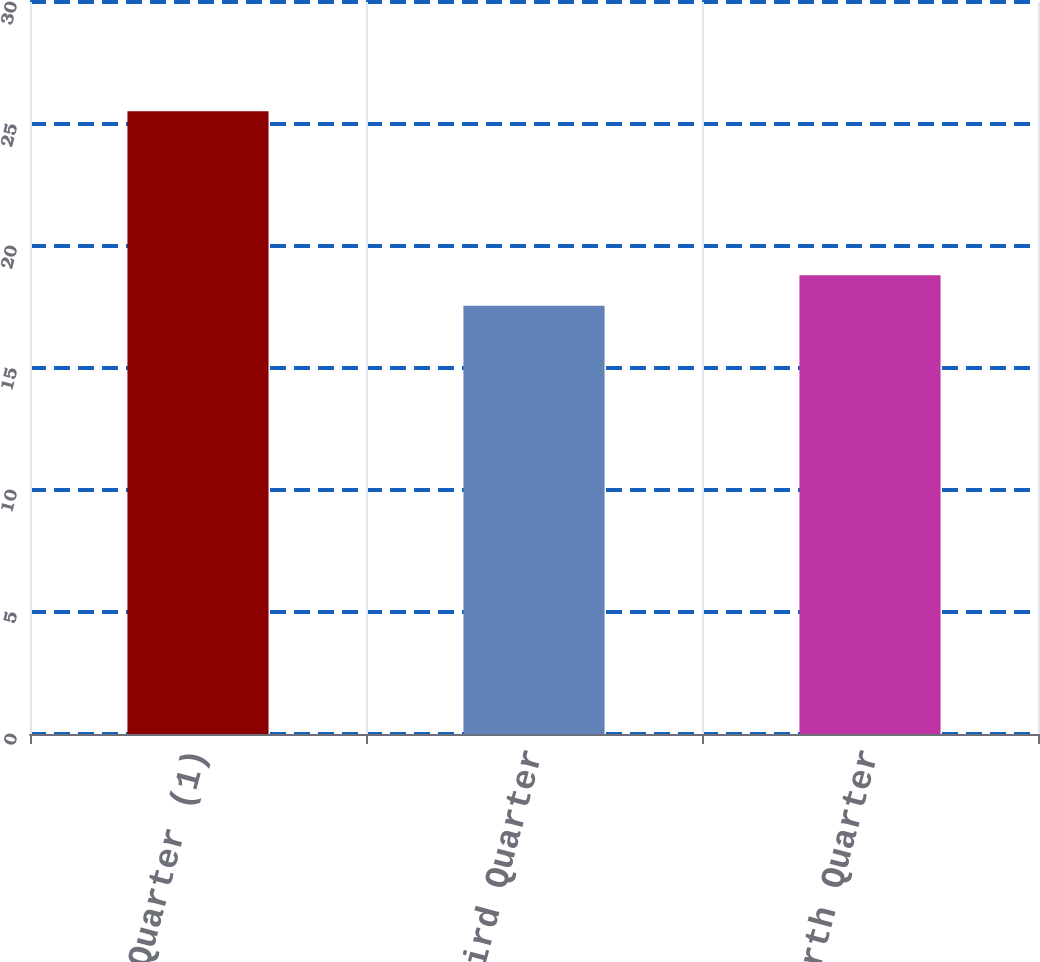Convert chart. <chart><loc_0><loc_0><loc_500><loc_500><bar_chart><fcel>Second Quarter (1)<fcel>Third Quarter<fcel>Fourth Quarter<nl><fcel>25.52<fcel>17.55<fcel>18.8<nl></chart> 